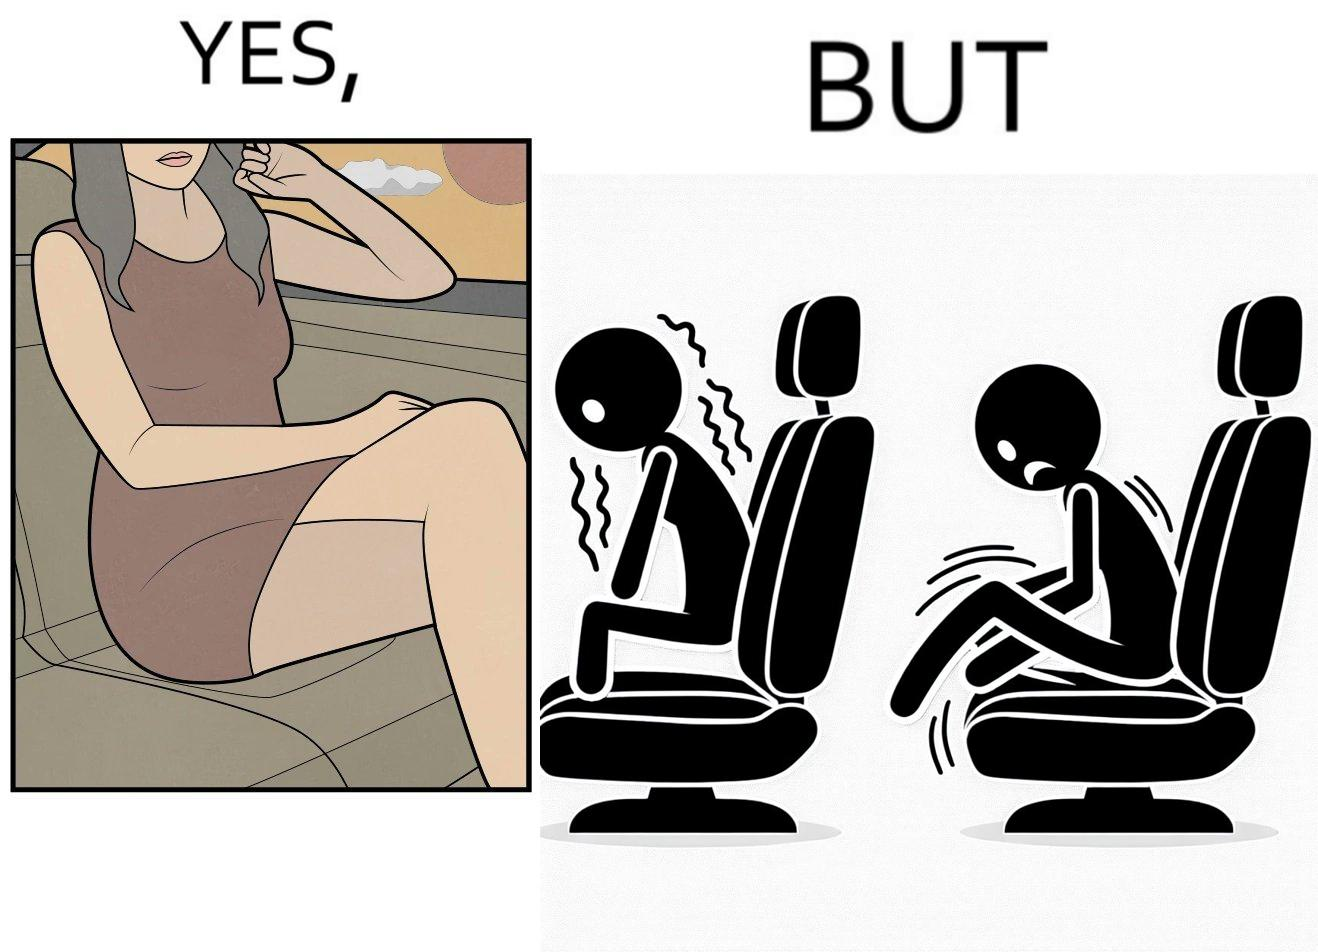Explain the humor or irony in this image. The image is ironic, because the woman is wearing a short dress to look stylish but she had to face inconvenience while travelling in car due to her short dress only. 